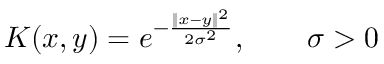<formula> <loc_0><loc_0><loc_500><loc_500>K ( x , y ) = e ^ { - { \frac { \| x - y \| ^ { 2 } } { 2 \sigma ^ { 2 } } } } , \quad \sigma > 0</formula> 